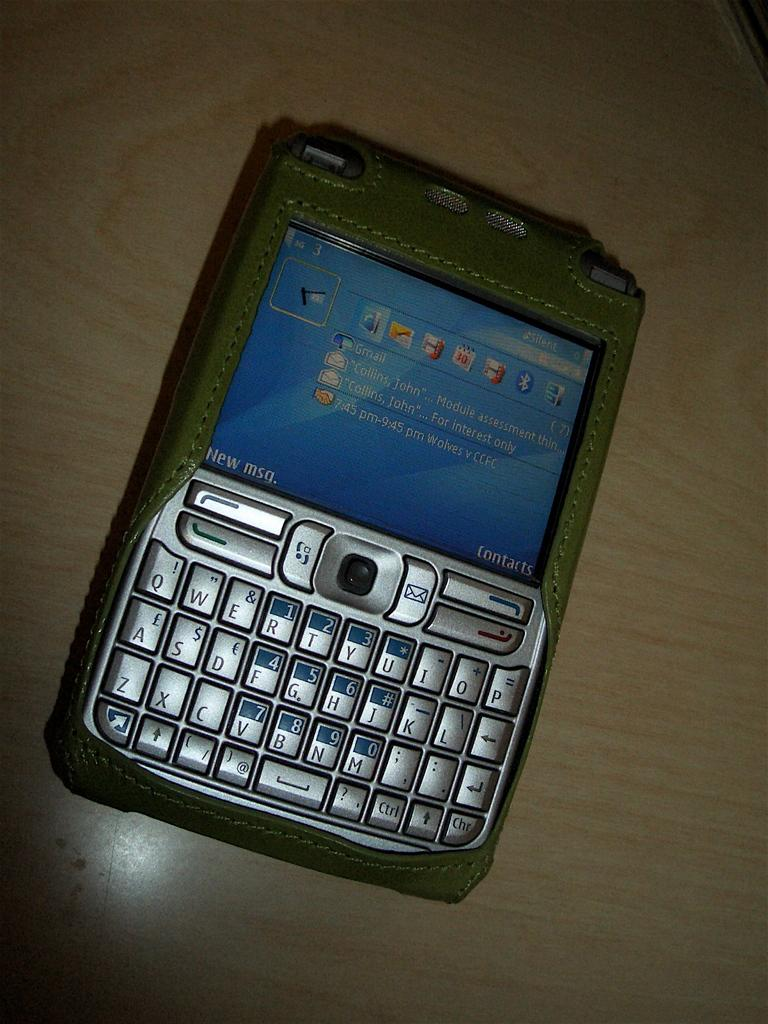<image>
Offer a succinct explanation of the picture presented. A phone is turned on sitting on top of a table with a new msg and contacts text showing. 